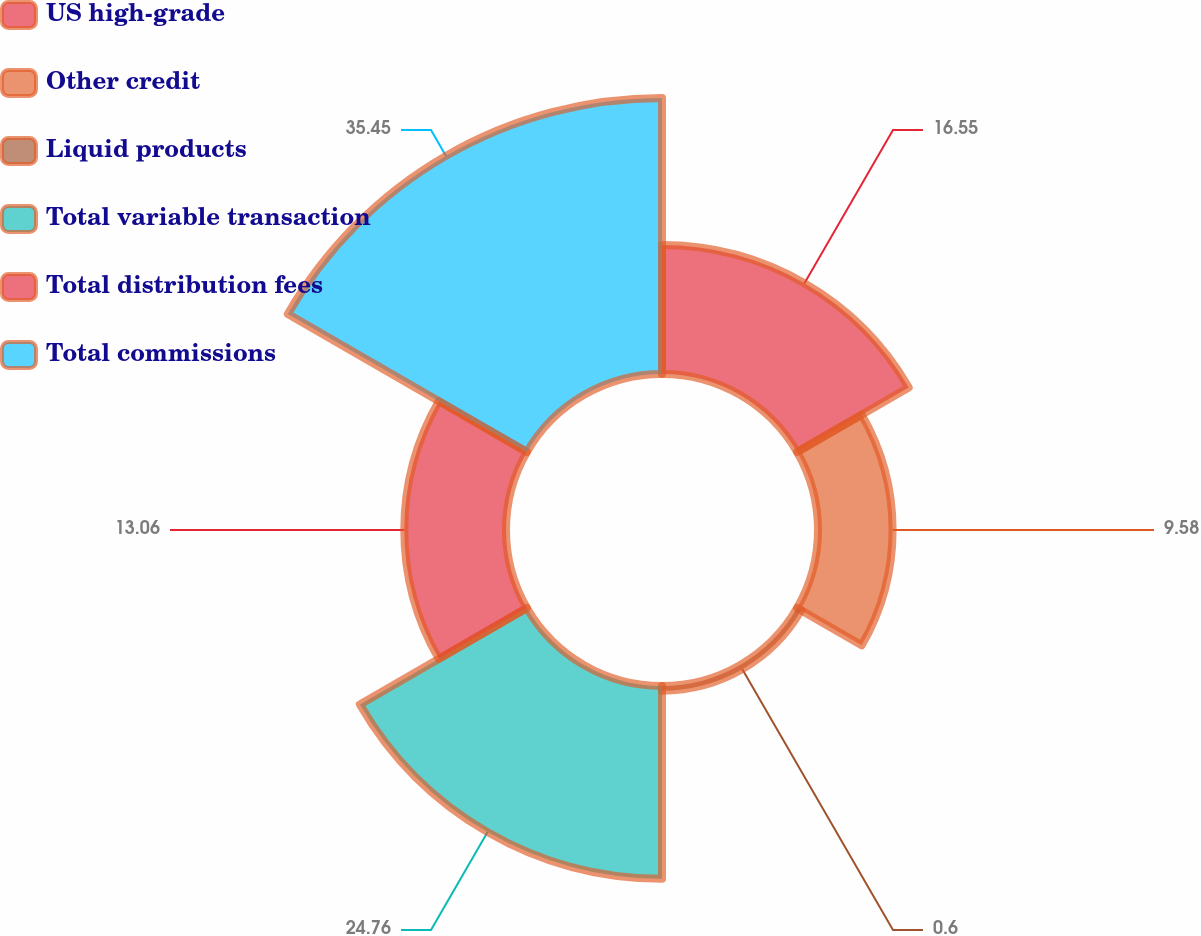<chart> <loc_0><loc_0><loc_500><loc_500><pie_chart><fcel>US high-grade<fcel>Other credit<fcel>Liquid products<fcel>Total variable transaction<fcel>Total distribution fees<fcel>Total commissions<nl><fcel>16.55%<fcel>9.58%<fcel>0.6%<fcel>24.76%<fcel>13.06%<fcel>35.44%<nl></chart> 